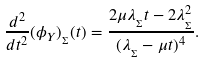<formula> <loc_0><loc_0><loc_500><loc_500>\frac { d ^ { 2 } } { d t ^ { 2 } } ( \phi _ { Y } ) _ { _ { \Sigma } } ( t ) = \frac { 2 \mu \lambda _ { _ { \Sigma } } t - 2 \lambda _ { _ { \Sigma } } ^ { 2 } } { ( \lambda _ { _ { \Sigma } } - \mu t ) ^ { 4 } } .</formula> 